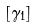<formula> <loc_0><loc_0><loc_500><loc_500>[ \gamma _ { 1 } ]</formula> 